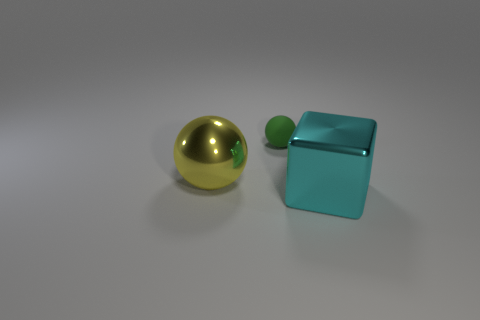Add 2 matte things. How many objects exist? 5 Subtract all yellow balls. How many balls are left? 1 Subtract all balls. How many objects are left? 1 Subtract all tiny brown metallic cylinders. Subtract all small objects. How many objects are left? 2 Add 3 large cyan cubes. How many large cyan cubes are left? 4 Add 1 small blue shiny blocks. How many small blue shiny blocks exist? 1 Subtract 0 yellow cubes. How many objects are left? 3 Subtract all purple cubes. Subtract all brown cylinders. How many cubes are left? 1 Subtract all yellow balls. How many gray blocks are left? 0 